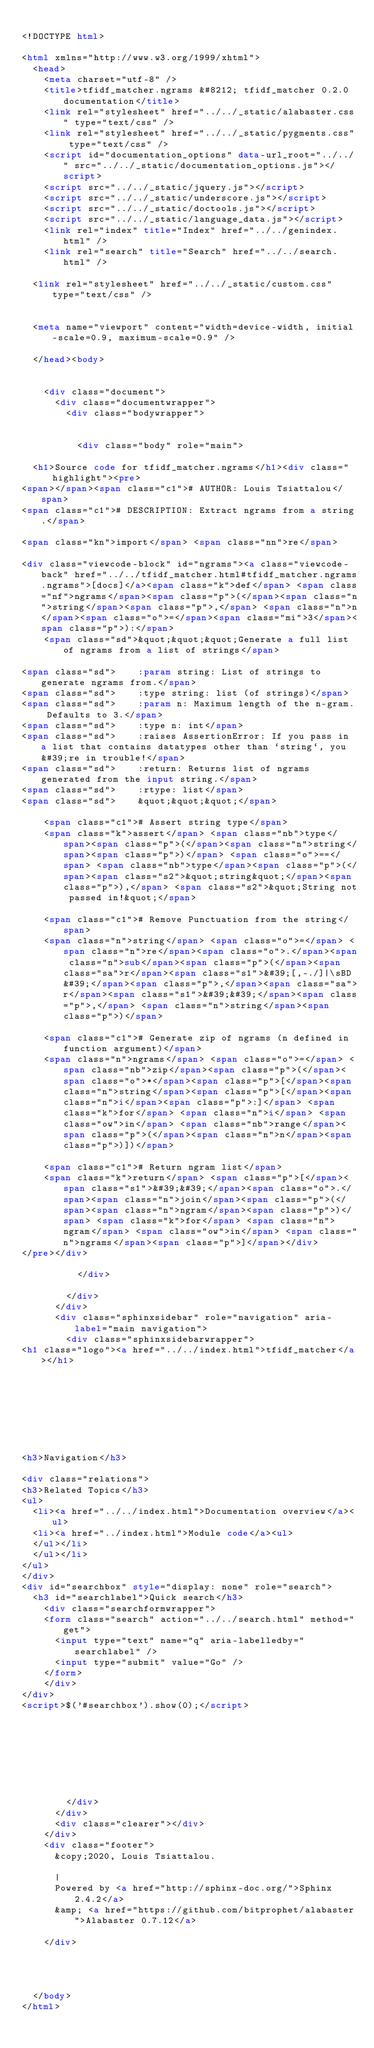Convert code to text. <code><loc_0><loc_0><loc_500><loc_500><_HTML_>
<!DOCTYPE html>

<html xmlns="http://www.w3.org/1999/xhtml">
  <head>
    <meta charset="utf-8" />
    <title>tfidf_matcher.ngrams &#8212; tfidf_matcher 0.2.0 documentation</title>
    <link rel="stylesheet" href="../../_static/alabaster.css" type="text/css" />
    <link rel="stylesheet" href="../../_static/pygments.css" type="text/css" />
    <script id="documentation_options" data-url_root="../../" src="../../_static/documentation_options.js"></script>
    <script src="../../_static/jquery.js"></script>
    <script src="../../_static/underscore.js"></script>
    <script src="../../_static/doctools.js"></script>
    <script src="../../_static/language_data.js"></script>
    <link rel="index" title="Index" href="../../genindex.html" />
    <link rel="search" title="Search" href="../../search.html" />
   
  <link rel="stylesheet" href="../../_static/custom.css" type="text/css" />
  
  
  <meta name="viewport" content="width=device-width, initial-scale=0.9, maximum-scale=0.9" />

  </head><body>
  

    <div class="document">
      <div class="documentwrapper">
        <div class="bodywrapper">
          

          <div class="body" role="main">
            
  <h1>Source code for tfidf_matcher.ngrams</h1><div class="highlight"><pre>
<span></span><span class="c1"># AUTHOR: Louis Tsiattalou</span>
<span class="c1"># DESCRIPTION: Extract ngrams from a string.</span>

<span class="kn">import</span> <span class="nn">re</span>

<div class="viewcode-block" id="ngrams"><a class="viewcode-back" href="../../tfidf_matcher.html#tfidf_matcher.ngrams.ngrams">[docs]</a><span class="k">def</span> <span class="nf">ngrams</span><span class="p">(</span><span class="n">string</span><span class="p">,</span> <span class="n">n</span><span class="o">=</span><span class="mi">3</span><span class="p">):</span>
    <span class="sd">&quot;&quot;&quot;Generate a full list of ngrams from a list of strings</span>

<span class="sd">    :param string: List of strings to generate ngrams from.</span>
<span class="sd">    :type string: list (of strings)</span>
<span class="sd">    :param n: Maximum length of the n-gram. Defaults to 3.</span>
<span class="sd">    :type n: int</span>
<span class="sd">    :raises AssertionError: If you pass in a list that contains datatypes other than `string`, you&#39;re in trouble!</span>
<span class="sd">    :return: Returns list of ngrams generated from the input string.</span>
<span class="sd">    :rtype: list</span>
<span class="sd">    &quot;&quot;&quot;</span>

    <span class="c1"># Assert string type</span>
    <span class="k">assert</span> <span class="nb">type</span><span class="p">(</span><span class="n">string</span><span class="p">)</span> <span class="o">==</span> <span class="nb">type</span><span class="p">(</span><span class="s2">&quot;string&quot;</span><span class="p">),</span> <span class="s2">&quot;String not passed in!&quot;</span>

    <span class="c1"># Remove Punctuation from the string</span>
    <span class="n">string</span> <span class="o">=</span> <span class="n">re</span><span class="o">.</span><span class="n">sub</span><span class="p">(</span><span class="sa">r</span><span class="s1">&#39;[,-./]|\sBD&#39;</span><span class="p">,</span><span class="sa">r</span><span class="s1">&#39;&#39;</span><span class="p">,</span> <span class="n">string</span><span class="p">)</span>

    <span class="c1"># Generate zip of ngrams (n defined in function argument)</span>
    <span class="n">ngrams</span> <span class="o">=</span> <span class="nb">zip</span><span class="p">(</span><span class="o">*</span><span class="p">[</span><span class="n">string</span><span class="p">[</span><span class="n">i</span><span class="p">:]</span> <span class="k">for</span> <span class="n">i</span> <span class="ow">in</span> <span class="nb">range</span><span class="p">(</span><span class="n">n</span><span class="p">)])</span>

    <span class="c1"># Return ngram list</span>
    <span class="k">return</span> <span class="p">[</span><span class="s1">&#39;&#39;</span><span class="o">.</span><span class="n">join</span><span class="p">(</span><span class="n">ngram</span><span class="p">)</span> <span class="k">for</span> <span class="n">ngram</span> <span class="ow">in</span> <span class="n">ngrams</span><span class="p">]</span></div>
</pre></div>

          </div>
          
        </div>
      </div>
      <div class="sphinxsidebar" role="navigation" aria-label="main navigation">
        <div class="sphinxsidebarwrapper">
<h1 class="logo"><a href="../../index.html">tfidf_matcher</a></h1>








<h3>Navigation</h3>

<div class="relations">
<h3>Related Topics</h3>
<ul>
  <li><a href="../../index.html">Documentation overview</a><ul>
  <li><a href="../index.html">Module code</a><ul>
  </ul></li>
  </ul></li>
</ul>
</div>
<div id="searchbox" style="display: none" role="search">
  <h3 id="searchlabel">Quick search</h3>
    <div class="searchformwrapper">
    <form class="search" action="../../search.html" method="get">
      <input type="text" name="q" aria-labelledby="searchlabel" />
      <input type="submit" value="Go" />
    </form>
    </div>
</div>
<script>$('#searchbox').show(0);</script>








        </div>
      </div>
      <div class="clearer"></div>
    </div>
    <div class="footer">
      &copy;2020, Louis Tsiattalou.
      
      |
      Powered by <a href="http://sphinx-doc.org/">Sphinx 2.4.2</a>
      &amp; <a href="https://github.com/bitprophet/alabaster">Alabaster 0.7.12</a>
      
    </div>

    

    
  </body>
</html></code> 